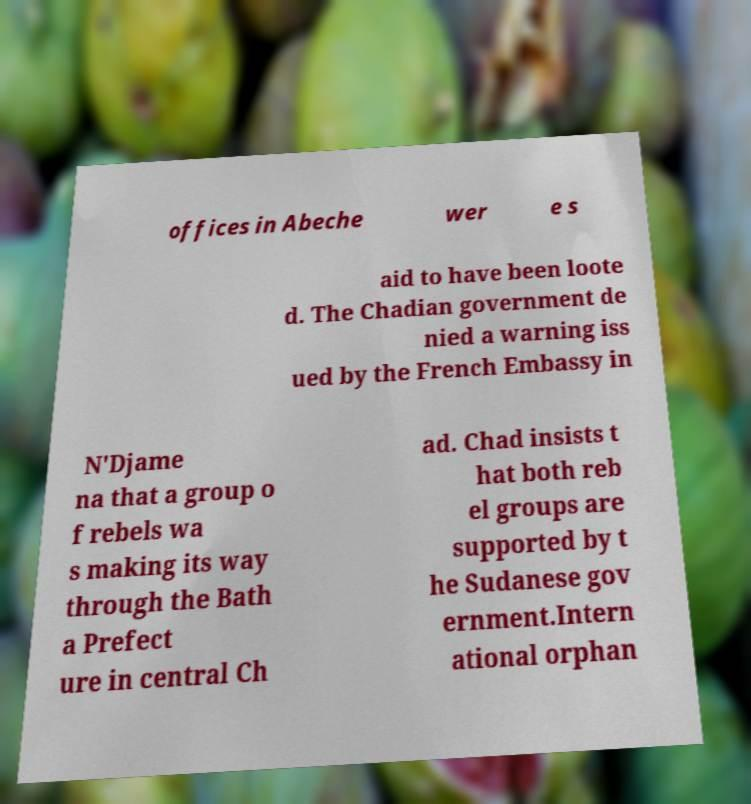There's text embedded in this image that I need extracted. Can you transcribe it verbatim? offices in Abeche wer e s aid to have been loote d. The Chadian government de nied a warning iss ued by the French Embassy in N'Djame na that a group o f rebels wa s making its way through the Bath a Prefect ure in central Ch ad. Chad insists t hat both reb el groups are supported by t he Sudanese gov ernment.Intern ational orphan 